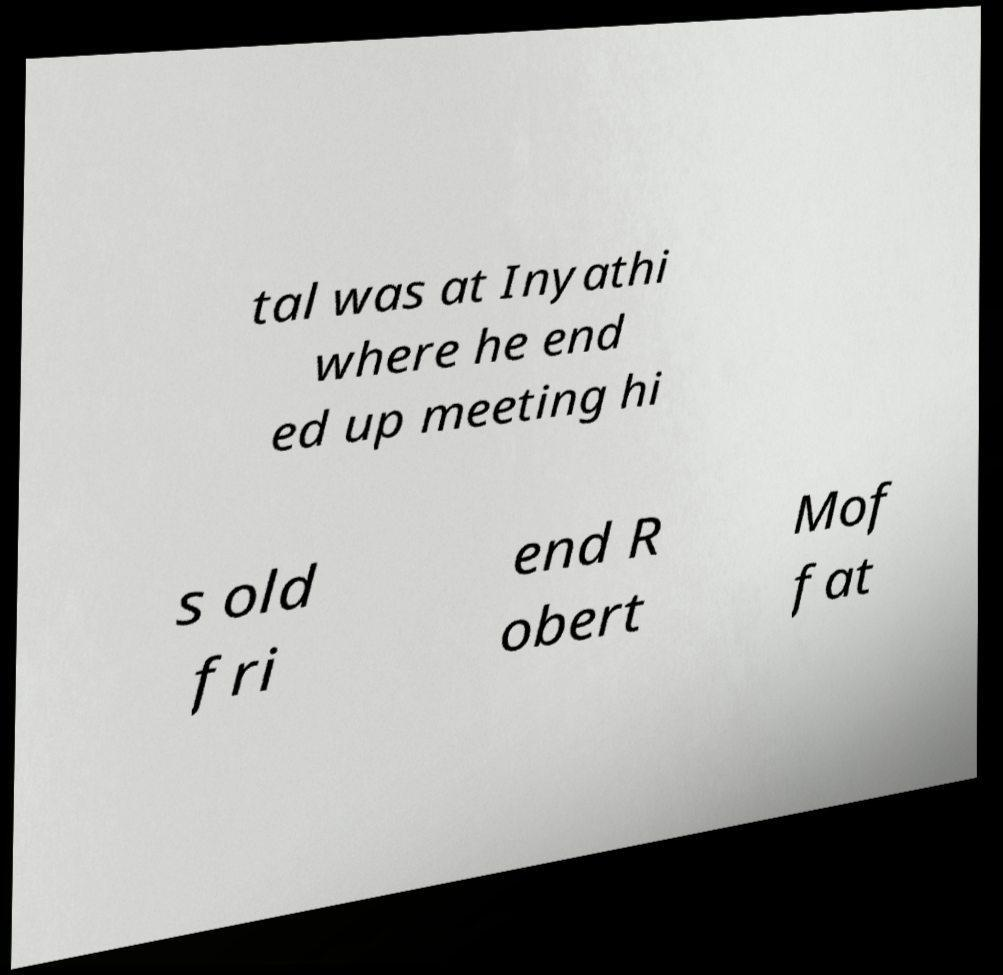There's text embedded in this image that I need extracted. Can you transcribe it verbatim? tal was at Inyathi where he end ed up meeting hi s old fri end R obert Mof fat 